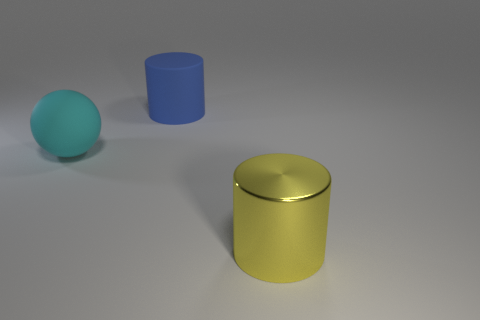Add 1 big blue cylinders. How many objects exist? 4 Subtract all cylinders. How many objects are left? 1 Subtract all large red matte blocks. Subtract all large blue objects. How many objects are left? 2 Add 3 yellow metal things. How many yellow metal things are left? 4 Add 3 big metallic cylinders. How many big metallic cylinders exist? 4 Subtract 0 red blocks. How many objects are left? 3 